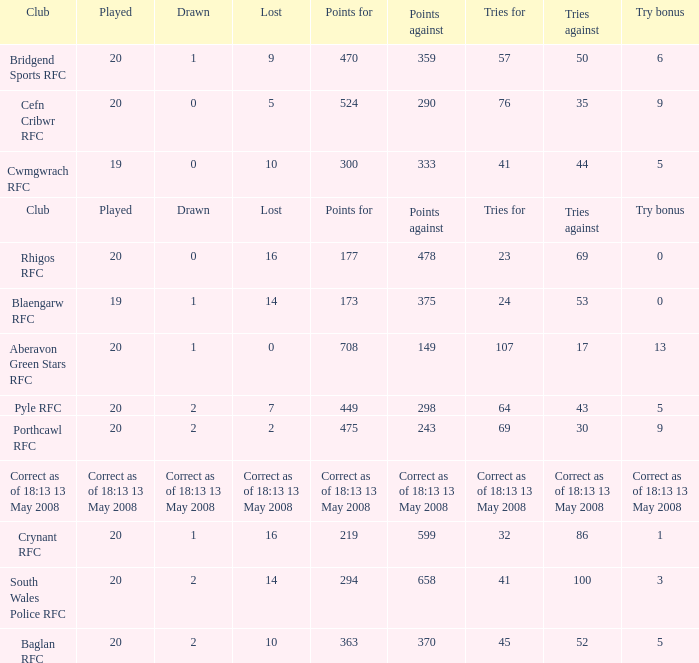What is the points when the try bonus is 1? 219.0. 